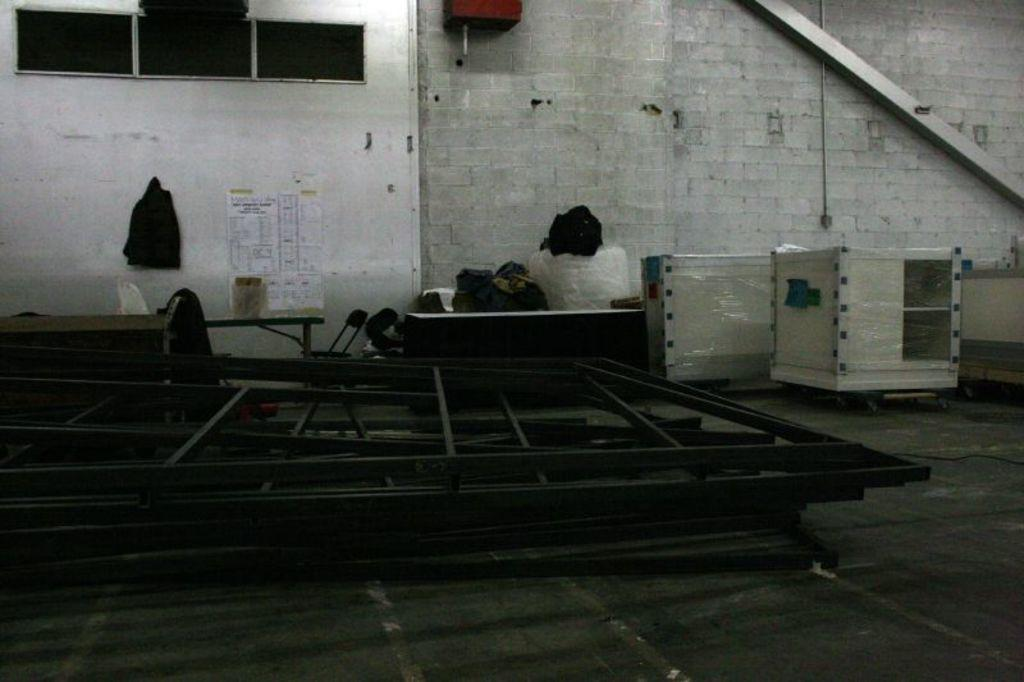What object can be seen in the image that might be used for carrying items? There is a bag in the image that might be used for carrying items. What is covering the table in the image? There are covers on the table in the image. What is attached to the wall in the background of the image? There is a paper attached to the wall in the background of the image. What color is the wall in the image? The wall is white in the image. How many windows are visible in the image? There are three windows in the image. Can you see any ducks or rabbits pulling the bag in the image? No, there are no ducks or rabbits pulling the bag in the image. 